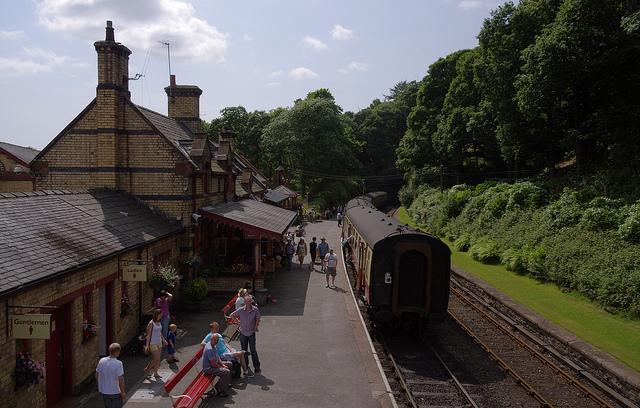In what direction will the train go next with respect to the person taking this person? away 